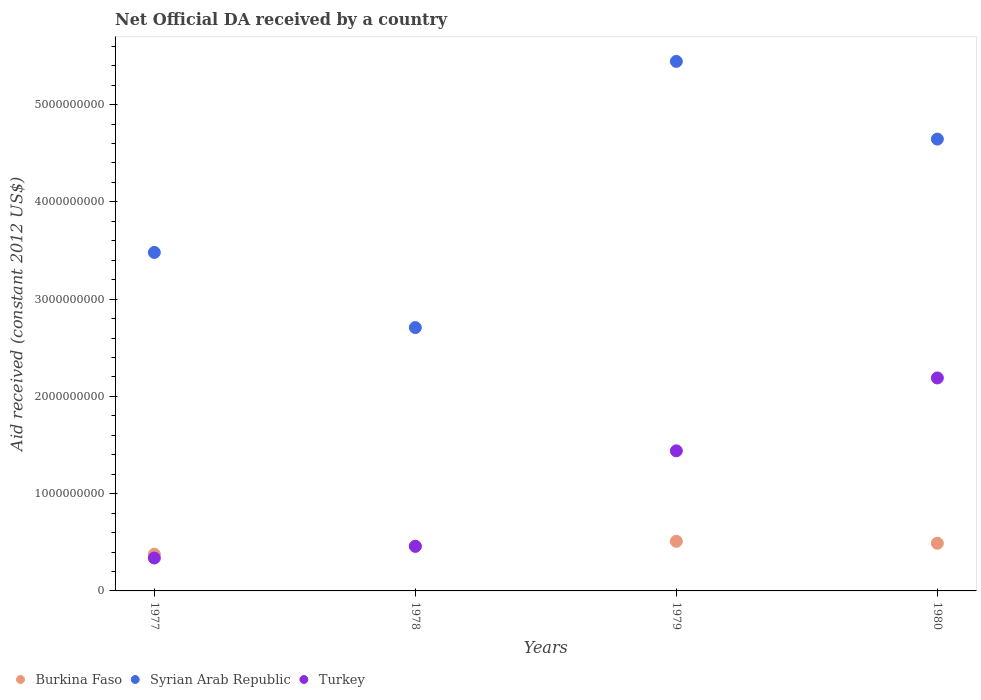How many different coloured dotlines are there?
Provide a short and direct response. 3. What is the net official development assistance aid received in Burkina Faso in 1980?
Give a very brief answer. 4.90e+08. Across all years, what is the maximum net official development assistance aid received in Burkina Faso?
Make the answer very short. 5.10e+08. Across all years, what is the minimum net official development assistance aid received in Syrian Arab Republic?
Give a very brief answer. 2.71e+09. In which year was the net official development assistance aid received in Syrian Arab Republic maximum?
Offer a terse response. 1979. What is the total net official development assistance aid received in Turkey in the graph?
Ensure brevity in your answer.  4.43e+09. What is the difference between the net official development assistance aid received in Syrian Arab Republic in 1978 and that in 1979?
Your answer should be very brief. -2.74e+09. What is the difference between the net official development assistance aid received in Turkey in 1978 and the net official development assistance aid received in Burkina Faso in 1980?
Make the answer very short. -3.16e+07. What is the average net official development assistance aid received in Syrian Arab Republic per year?
Provide a succinct answer. 4.07e+09. In the year 1978, what is the difference between the net official development assistance aid received in Turkey and net official development assistance aid received in Burkina Faso?
Your answer should be compact. -1.38e+06. In how many years, is the net official development assistance aid received in Syrian Arab Republic greater than 3400000000 US$?
Ensure brevity in your answer.  3. What is the ratio of the net official development assistance aid received in Syrian Arab Republic in 1979 to that in 1980?
Ensure brevity in your answer.  1.17. Is the difference between the net official development assistance aid received in Turkey in 1977 and 1978 greater than the difference between the net official development assistance aid received in Burkina Faso in 1977 and 1978?
Provide a succinct answer. No. What is the difference between the highest and the second highest net official development assistance aid received in Turkey?
Provide a succinct answer. 7.49e+08. What is the difference between the highest and the lowest net official development assistance aid received in Syrian Arab Republic?
Provide a short and direct response. 2.74e+09. Is the sum of the net official development assistance aid received in Burkina Faso in 1977 and 1978 greater than the maximum net official development assistance aid received in Syrian Arab Republic across all years?
Give a very brief answer. No. Is it the case that in every year, the sum of the net official development assistance aid received in Burkina Faso and net official development assistance aid received in Syrian Arab Republic  is greater than the net official development assistance aid received in Turkey?
Offer a very short reply. Yes. Does the net official development assistance aid received in Syrian Arab Republic monotonically increase over the years?
Your answer should be very brief. No. Is the net official development assistance aid received in Syrian Arab Republic strictly greater than the net official development assistance aid received in Turkey over the years?
Give a very brief answer. Yes. Is the net official development assistance aid received in Turkey strictly less than the net official development assistance aid received in Burkina Faso over the years?
Offer a terse response. No. How many dotlines are there?
Your response must be concise. 3. How many years are there in the graph?
Provide a short and direct response. 4. What is the difference between two consecutive major ticks on the Y-axis?
Your answer should be very brief. 1.00e+09. Does the graph contain grids?
Keep it short and to the point. No. What is the title of the graph?
Make the answer very short. Net Official DA received by a country. Does "Kenya" appear as one of the legend labels in the graph?
Your answer should be very brief. No. What is the label or title of the Y-axis?
Make the answer very short. Aid received (constant 2012 US$). What is the Aid received (constant 2012 US$) of Burkina Faso in 1977?
Offer a terse response. 3.77e+08. What is the Aid received (constant 2012 US$) of Syrian Arab Republic in 1977?
Give a very brief answer. 3.48e+09. What is the Aid received (constant 2012 US$) of Turkey in 1977?
Make the answer very short. 3.38e+08. What is the Aid received (constant 2012 US$) of Burkina Faso in 1978?
Ensure brevity in your answer.  4.60e+08. What is the Aid received (constant 2012 US$) of Syrian Arab Republic in 1978?
Your answer should be very brief. 2.71e+09. What is the Aid received (constant 2012 US$) of Turkey in 1978?
Offer a terse response. 4.58e+08. What is the Aid received (constant 2012 US$) in Burkina Faso in 1979?
Ensure brevity in your answer.  5.10e+08. What is the Aid received (constant 2012 US$) of Syrian Arab Republic in 1979?
Ensure brevity in your answer.  5.44e+09. What is the Aid received (constant 2012 US$) of Turkey in 1979?
Offer a very short reply. 1.44e+09. What is the Aid received (constant 2012 US$) of Burkina Faso in 1980?
Make the answer very short. 4.90e+08. What is the Aid received (constant 2012 US$) in Syrian Arab Republic in 1980?
Make the answer very short. 4.64e+09. What is the Aid received (constant 2012 US$) of Turkey in 1980?
Offer a very short reply. 2.19e+09. Across all years, what is the maximum Aid received (constant 2012 US$) of Burkina Faso?
Provide a succinct answer. 5.10e+08. Across all years, what is the maximum Aid received (constant 2012 US$) of Syrian Arab Republic?
Your response must be concise. 5.44e+09. Across all years, what is the maximum Aid received (constant 2012 US$) in Turkey?
Make the answer very short. 2.19e+09. Across all years, what is the minimum Aid received (constant 2012 US$) in Burkina Faso?
Ensure brevity in your answer.  3.77e+08. Across all years, what is the minimum Aid received (constant 2012 US$) of Syrian Arab Republic?
Keep it short and to the point. 2.71e+09. Across all years, what is the minimum Aid received (constant 2012 US$) of Turkey?
Keep it short and to the point. 3.38e+08. What is the total Aid received (constant 2012 US$) in Burkina Faso in the graph?
Give a very brief answer. 1.84e+09. What is the total Aid received (constant 2012 US$) in Syrian Arab Republic in the graph?
Keep it short and to the point. 1.63e+1. What is the total Aid received (constant 2012 US$) of Turkey in the graph?
Ensure brevity in your answer.  4.43e+09. What is the difference between the Aid received (constant 2012 US$) of Burkina Faso in 1977 and that in 1978?
Your answer should be very brief. -8.32e+07. What is the difference between the Aid received (constant 2012 US$) in Syrian Arab Republic in 1977 and that in 1978?
Provide a succinct answer. 7.73e+08. What is the difference between the Aid received (constant 2012 US$) of Turkey in 1977 and that in 1978?
Provide a succinct answer. -1.20e+08. What is the difference between the Aid received (constant 2012 US$) in Burkina Faso in 1977 and that in 1979?
Your answer should be very brief. -1.33e+08. What is the difference between the Aid received (constant 2012 US$) of Syrian Arab Republic in 1977 and that in 1979?
Provide a short and direct response. -1.96e+09. What is the difference between the Aid received (constant 2012 US$) in Turkey in 1977 and that in 1979?
Make the answer very short. -1.10e+09. What is the difference between the Aid received (constant 2012 US$) in Burkina Faso in 1977 and that in 1980?
Your answer should be compact. -1.13e+08. What is the difference between the Aid received (constant 2012 US$) in Syrian Arab Republic in 1977 and that in 1980?
Make the answer very short. -1.17e+09. What is the difference between the Aid received (constant 2012 US$) in Turkey in 1977 and that in 1980?
Your response must be concise. -1.85e+09. What is the difference between the Aid received (constant 2012 US$) in Burkina Faso in 1978 and that in 1979?
Keep it short and to the point. -5.03e+07. What is the difference between the Aid received (constant 2012 US$) in Syrian Arab Republic in 1978 and that in 1979?
Make the answer very short. -2.74e+09. What is the difference between the Aid received (constant 2012 US$) of Turkey in 1978 and that in 1979?
Your answer should be compact. -9.82e+08. What is the difference between the Aid received (constant 2012 US$) of Burkina Faso in 1978 and that in 1980?
Provide a short and direct response. -3.02e+07. What is the difference between the Aid received (constant 2012 US$) of Syrian Arab Republic in 1978 and that in 1980?
Make the answer very short. -1.94e+09. What is the difference between the Aid received (constant 2012 US$) of Turkey in 1978 and that in 1980?
Offer a very short reply. -1.73e+09. What is the difference between the Aid received (constant 2012 US$) of Burkina Faso in 1979 and that in 1980?
Ensure brevity in your answer.  2.01e+07. What is the difference between the Aid received (constant 2012 US$) of Syrian Arab Republic in 1979 and that in 1980?
Your response must be concise. 7.99e+08. What is the difference between the Aid received (constant 2012 US$) of Turkey in 1979 and that in 1980?
Your answer should be very brief. -7.49e+08. What is the difference between the Aid received (constant 2012 US$) in Burkina Faso in 1977 and the Aid received (constant 2012 US$) in Syrian Arab Republic in 1978?
Provide a succinct answer. -2.33e+09. What is the difference between the Aid received (constant 2012 US$) of Burkina Faso in 1977 and the Aid received (constant 2012 US$) of Turkey in 1978?
Keep it short and to the point. -8.18e+07. What is the difference between the Aid received (constant 2012 US$) in Syrian Arab Republic in 1977 and the Aid received (constant 2012 US$) in Turkey in 1978?
Your answer should be compact. 3.02e+09. What is the difference between the Aid received (constant 2012 US$) in Burkina Faso in 1977 and the Aid received (constant 2012 US$) in Syrian Arab Republic in 1979?
Ensure brevity in your answer.  -5.07e+09. What is the difference between the Aid received (constant 2012 US$) in Burkina Faso in 1977 and the Aid received (constant 2012 US$) in Turkey in 1979?
Your answer should be compact. -1.06e+09. What is the difference between the Aid received (constant 2012 US$) in Syrian Arab Republic in 1977 and the Aid received (constant 2012 US$) in Turkey in 1979?
Offer a terse response. 2.04e+09. What is the difference between the Aid received (constant 2012 US$) in Burkina Faso in 1977 and the Aid received (constant 2012 US$) in Syrian Arab Republic in 1980?
Your response must be concise. -4.27e+09. What is the difference between the Aid received (constant 2012 US$) of Burkina Faso in 1977 and the Aid received (constant 2012 US$) of Turkey in 1980?
Make the answer very short. -1.81e+09. What is the difference between the Aid received (constant 2012 US$) of Syrian Arab Republic in 1977 and the Aid received (constant 2012 US$) of Turkey in 1980?
Your answer should be compact. 1.29e+09. What is the difference between the Aid received (constant 2012 US$) in Burkina Faso in 1978 and the Aid received (constant 2012 US$) in Syrian Arab Republic in 1979?
Your answer should be very brief. -4.98e+09. What is the difference between the Aid received (constant 2012 US$) of Burkina Faso in 1978 and the Aid received (constant 2012 US$) of Turkey in 1979?
Offer a terse response. -9.80e+08. What is the difference between the Aid received (constant 2012 US$) of Syrian Arab Republic in 1978 and the Aid received (constant 2012 US$) of Turkey in 1979?
Your answer should be compact. 1.27e+09. What is the difference between the Aid received (constant 2012 US$) of Burkina Faso in 1978 and the Aid received (constant 2012 US$) of Syrian Arab Republic in 1980?
Your answer should be compact. -4.19e+09. What is the difference between the Aid received (constant 2012 US$) in Burkina Faso in 1978 and the Aid received (constant 2012 US$) in Turkey in 1980?
Ensure brevity in your answer.  -1.73e+09. What is the difference between the Aid received (constant 2012 US$) in Syrian Arab Republic in 1978 and the Aid received (constant 2012 US$) in Turkey in 1980?
Give a very brief answer. 5.18e+08. What is the difference between the Aid received (constant 2012 US$) in Burkina Faso in 1979 and the Aid received (constant 2012 US$) in Syrian Arab Republic in 1980?
Your answer should be very brief. -4.13e+09. What is the difference between the Aid received (constant 2012 US$) of Burkina Faso in 1979 and the Aid received (constant 2012 US$) of Turkey in 1980?
Your response must be concise. -1.68e+09. What is the difference between the Aid received (constant 2012 US$) in Syrian Arab Republic in 1979 and the Aid received (constant 2012 US$) in Turkey in 1980?
Ensure brevity in your answer.  3.25e+09. What is the average Aid received (constant 2012 US$) of Burkina Faso per year?
Offer a very short reply. 4.59e+08. What is the average Aid received (constant 2012 US$) in Syrian Arab Republic per year?
Give a very brief answer. 4.07e+09. What is the average Aid received (constant 2012 US$) in Turkey per year?
Keep it short and to the point. 1.11e+09. In the year 1977, what is the difference between the Aid received (constant 2012 US$) of Burkina Faso and Aid received (constant 2012 US$) of Syrian Arab Republic?
Provide a succinct answer. -3.10e+09. In the year 1977, what is the difference between the Aid received (constant 2012 US$) in Burkina Faso and Aid received (constant 2012 US$) in Turkey?
Provide a short and direct response. 3.82e+07. In the year 1977, what is the difference between the Aid received (constant 2012 US$) of Syrian Arab Republic and Aid received (constant 2012 US$) of Turkey?
Your answer should be very brief. 3.14e+09. In the year 1978, what is the difference between the Aid received (constant 2012 US$) of Burkina Faso and Aid received (constant 2012 US$) of Syrian Arab Republic?
Offer a very short reply. -2.25e+09. In the year 1978, what is the difference between the Aid received (constant 2012 US$) of Burkina Faso and Aid received (constant 2012 US$) of Turkey?
Your answer should be compact. 1.38e+06. In the year 1978, what is the difference between the Aid received (constant 2012 US$) of Syrian Arab Republic and Aid received (constant 2012 US$) of Turkey?
Offer a terse response. 2.25e+09. In the year 1979, what is the difference between the Aid received (constant 2012 US$) in Burkina Faso and Aid received (constant 2012 US$) in Syrian Arab Republic?
Offer a very short reply. -4.93e+09. In the year 1979, what is the difference between the Aid received (constant 2012 US$) in Burkina Faso and Aid received (constant 2012 US$) in Turkey?
Your answer should be very brief. -9.30e+08. In the year 1979, what is the difference between the Aid received (constant 2012 US$) in Syrian Arab Republic and Aid received (constant 2012 US$) in Turkey?
Offer a very short reply. 4.00e+09. In the year 1980, what is the difference between the Aid received (constant 2012 US$) of Burkina Faso and Aid received (constant 2012 US$) of Syrian Arab Republic?
Offer a terse response. -4.15e+09. In the year 1980, what is the difference between the Aid received (constant 2012 US$) of Burkina Faso and Aid received (constant 2012 US$) of Turkey?
Make the answer very short. -1.70e+09. In the year 1980, what is the difference between the Aid received (constant 2012 US$) of Syrian Arab Republic and Aid received (constant 2012 US$) of Turkey?
Your response must be concise. 2.46e+09. What is the ratio of the Aid received (constant 2012 US$) of Burkina Faso in 1977 to that in 1978?
Give a very brief answer. 0.82. What is the ratio of the Aid received (constant 2012 US$) in Syrian Arab Republic in 1977 to that in 1978?
Keep it short and to the point. 1.29. What is the ratio of the Aid received (constant 2012 US$) in Turkey in 1977 to that in 1978?
Your response must be concise. 0.74. What is the ratio of the Aid received (constant 2012 US$) of Burkina Faso in 1977 to that in 1979?
Your answer should be very brief. 0.74. What is the ratio of the Aid received (constant 2012 US$) of Syrian Arab Republic in 1977 to that in 1979?
Make the answer very short. 0.64. What is the ratio of the Aid received (constant 2012 US$) in Turkey in 1977 to that in 1979?
Offer a terse response. 0.23. What is the ratio of the Aid received (constant 2012 US$) in Burkina Faso in 1977 to that in 1980?
Your response must be concise. 0.77. What is the ratio of the Aid received (constant 2012 US$) of Syrian Arab Republic in 1977 to that in 1980?
Ensure brevity in your answer.  0.75. What is the ratio of the Aid received (constant 2012 US$) in Turkey in 1977 to that in 1980?
Your answer should be very brief. 0.15. What is the ratio of the Aid received (constant 2012 US$) of Burkina Faso in 1978 to that in 1979?
Offer a very short reply. 0.9. What is the ratio of the Aid received (constant 2012 US$) in Syrian Arab Republic in 1978 to that in 1979?
Give a very brief answer. 0.5. What is the ratio of the Aid received (constant 2012 US$) of Turkey in 1978 to that in 1979?
Make the answer very short. 0.32. What is the ratio of the Aid received (constant 2012 US$) of Burkina Faso in 1978 to that in 1980?
Ensure brevity in your answer.  0.94. What is the ratio of the Aid received (constant 2012 US$) of Syrian Arab Republic in 1978 to that in 1980?
Offer a very short reply. 0.58. What is the ratio of the Aid received (constant 2012 US$) of Turkey in 1978 to that in 1980?
Provide a short and direct response. 0.21. What is the ratio of the Aid received (constant 2012 US$) in Burkina Faso in 1979 to that in 1980?
Keep it short and to the point. 1.04. What is the ratio of the Aid received (constant 2012 US$) of Syrian Arab Republic in 1979 to that in 1980?
Your response must be concise. 1.17. What is the ratio of the Aid received (constant 2012 US$) in Turkey in 1979 to that in 1980?
Offer a very short reply. 0.66. What is the difference between the highest and the second highest Aid received (constant 2012 US$) in Burkina Faso?
Provide a succinct answer. 2.01e+07. What is the difference between the highest and the second highest Aid received (constant 2012 US$) of Syrian Arab Republic?
Make the answer very short. 7.99e+08. What is the difference between the highest and the second highest Aid received (constant 2012 US$) of Turkey?
Give a very brief answer. 7.49e+08. What is the difference between the highest and the lowest Aid received (constant 2012 US$) in Burkina Faso?
Your answer should be very brief. 1.33e+08. What is the difference between the highest and the lowest Aid received (constant 2012 US$) in Syrian Arab Republic?
Keep it short and to the point. 2.74e+09. What is the difference between the highest and the lowest Aid received (constant 2012 US$) in Turkey?
Provide a succinct answer. 1.85e+09. 